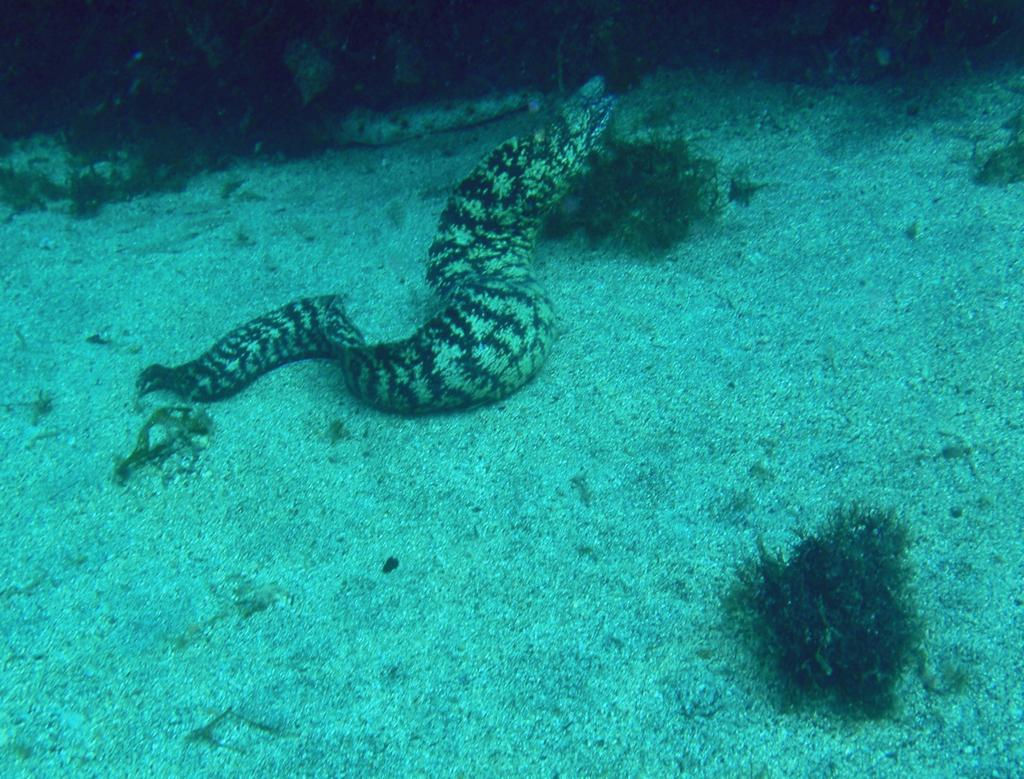What type of animal is present in the image? There is a snake in the image. What is the snake situated in or near? The image shows plants in the water, which suggests that the snake may be in or near the water. What type of attraction can be seen in the background of the image? There is no attraction visible in the image; it only features a snake and plants in the water. 